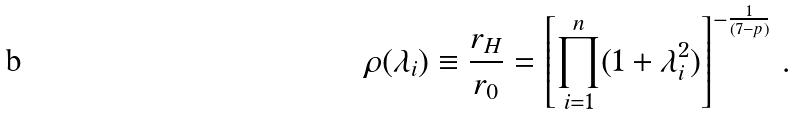<formula> <loc_0><loc_0><loc_500><loc_500>\rho ( \lambda _ { i } ) \equiv \frac { r _ { H } } { r _ { 0 } } = \left [ \prod _ { i = 1 } ^ { n } ( 1 + \lambda _ { i } ^ { 2 } ) \right ] ^ { - { \frac { 1 } { ( 7 - p ) } } } \, .</formula> 